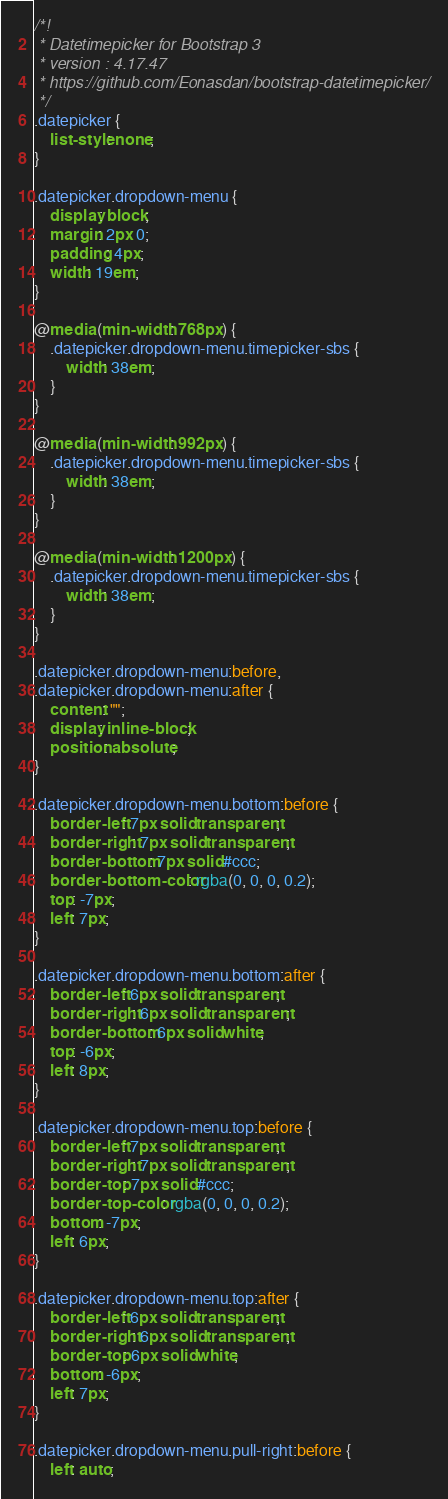<code> <loc_0><loc_0><loc_500><loc_500><_CSS_>/*!
 * Datetimepicker for Bootstrap 3
 * version : 4.17.47
 * https://github.com/Eonasdan/bootstrap-datetimepicker/
 */
.datepicker {
	list-style: none;
}

.datepicker.dropdown-menu {
	display: block;
	margin: 2px 0;
	padding: 4px;
	width: 19em;
}

@media (min-width: 768px) {
	.datepicker.dropdown-menu.timepicker-sbs {
		width: 38em;
	}
}

@media (min-width: 992px) {
	.datepicker.dropdown-menu.timepicker-sbs {
		width: 38em;
	}
}

@media (min-width: 1200px) {
	.datepicker.dropdown-menu.timepicker-sbs {
		width: 38em;
	}
}

.datepicker.dropdown-menu:before,
.datepicker.dropdown-menu:after {
	content: "";
	display: inline-block;
	position: absolute;
}

.datepicker.dropdown-menu.bottom:before {
	border-left: 7px solid transparent;
	border-right: 7px solid transparent;
	border-bottom: 7px solid #ccc;
	border-bottom-color: rgba(0, 0, 0, 0.2);
	top: -7px;
	left: 7px;
}

.datepicker.dropdown-menu.bottom:after {
	border-left: 6px solid transparent;
	border-right: 6px solid transparent;
	border-bottom: 6px solid white;
	top: -6px;
	left: 8px;
}

.datepicker.dropdown-menu.top:before {
	border-left: 7px solid transparent;
	border-right: 7px solid transparent;
	border-top: 7px solid #ccc;
	border-top-color: rgba(0, 0, 0, 0.2);
	bottom: -7px;
	left: 6px;
}

.datepicker.dropdown-menu.top:after {
	border-left: 6px solid transparent;
	border-right: 6px solid transparent;
	border-top: 6px solid white;
	bottom: -6px;
	left: 7px;
}

.datepicker.dropdown-menu.pull-right:before {
	left: auto;</code> 